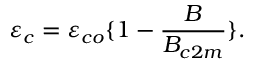Convert formula to latex. <formula><loc_0><loc_0><loc_500><loc_500>\varepsilon _ { c } = \varepsilon _ { c o } \{ 1 - { \frac { B } { B _ { c 2 m } } } \} .</formula> 